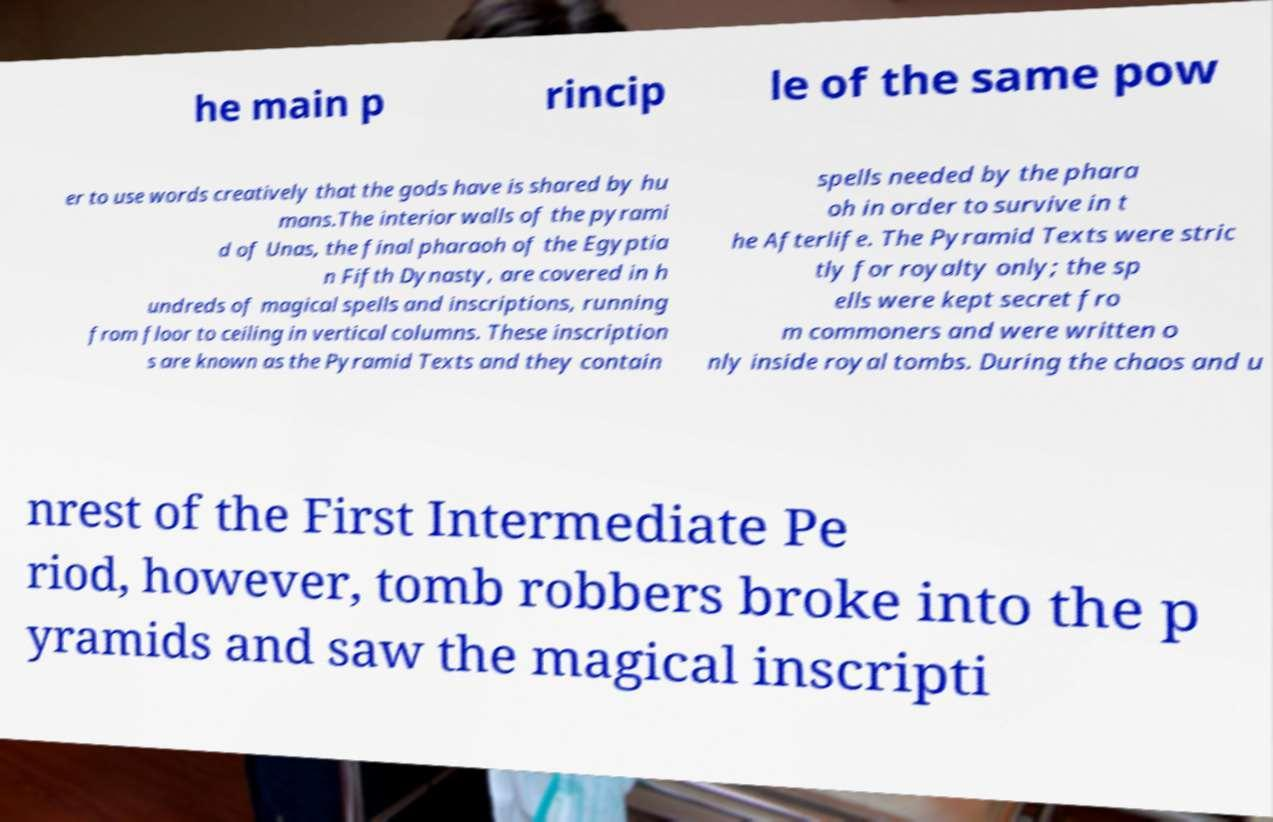I need the written content from this picture converted into text. Can you do that? he main p rincip le of the same pow er to use words creatively that the gods have is shared by hu mans.The interior walls of the pyrami d of Unas, the final pharaoh of the Egyptia n Fifth Dynasty, are covered in h undreds of magical spells and inscriptions, running from floor to ceiling in vertical columns. These inscription s are known as the Pyramid Texts and they contain spells needed by the phara oh in order to survive in t he Afterlife. The Pyramid Texts were stric tly for royalty only; the sp ells were kept secret fro m commoners and were written o nly inside royal tombs. During the chaos and u nrest of the First Intermediate Pe riod, however, tomb robbers broke into the p yramids and saw the magical inscripti 